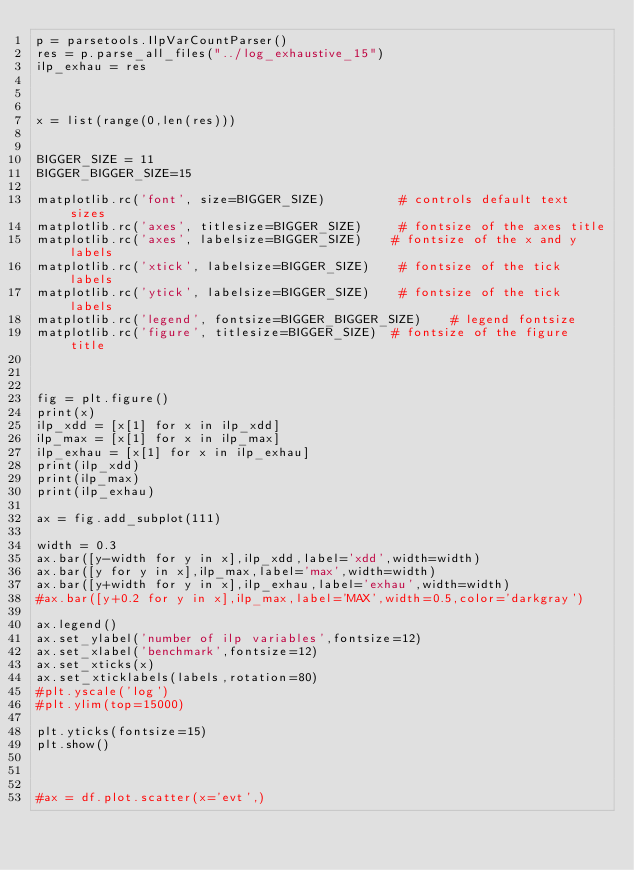<code> <loc_0><loc_0><loc_500><loc_500><_Python_>p = parsetools.IlpVarCountParser()
res = p.parse_all_files("../log_exhaustive_15")
ilp_exhau = res



x = list(range(0,len(res)))


BIGGER_SIZE = 11
BIGGER_BIGGER_SIZE=15

matplotlib.rc('font', size=BIGGER_SIZE)          # controls default text sizes
matplotlib.rc('axes', titlesize=BIGGER_SIZE)     # fontsize of the axes title
matplotlib.rc('axes', labelsize=BIGGER_SIZE)    # fontsize of the x and y labels
matplotlib.rc('xtick', labelsize=BIGGER_SIZE)    # fontsize of the tick labels
matplotlib.rc('ytick', labelsize=BIGGER_SIZE)    # fontsize of the tick labels
matplotlib.rc('legend', fontsize=BIGGER_BIGGER_SIZE)    # legend fontsize
matplotlib.rc('figure', titlesize=BIGGER_SIZE)  # fontsize of the figure title



fig = plt.figure()
print(x)
ilp_xdd = [x[1] for x in ilp_xdd]
ilp_max = [x[1] for x in ilp_max]
ilp_exhau = [x[1] for x in ilp_exhau]
print(ilp_xdd)
print(ilp_max)
print(ilp_exhau)

ax = fig.add_subplot(111)

width = 0.3
ax.bar([y-width for y in x],ilp_xdd,label='xdd',width=width)
ax.bar([y for y in x],ilp_max,label='max',width=width)
ax.bar([y+width for y in x],ilp_exhau,label='exhau',width=width)
#ax.bar([y+0.2 for y in x],ilp_max,label='MAX',width=0.5,color='darkgray')

ax.legend()
ax.set_ylabel('number of ilp variables',fontsize=12)
ax.set_xlabel('benchmark',fontsize=12)
ax.set_xticks(x)
ax.set_xticklabels(labels,rotation=80)
#plt.yscale('log')
#plt.ylim(top=15000)

plt.yticks(fontsize=15)
plt.show()



#ax = df.plot.scatter(x='evt',)
</code> 